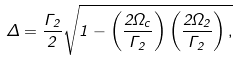Convert formula to latex. <formula><loc_0><loc_0><loc_500><loc_500>\Delta = \frac { \Gamma _ { 2 } } { 2 } \sqrt { 1 - \left ( \frac { 2 \Omega _ { c } } { \Gamma _ { 2 } } \right ) \left ( \frac { 2 \Omega _ { 2 } } { \Gamma _ { 2 } } \right ) , }</formula> 